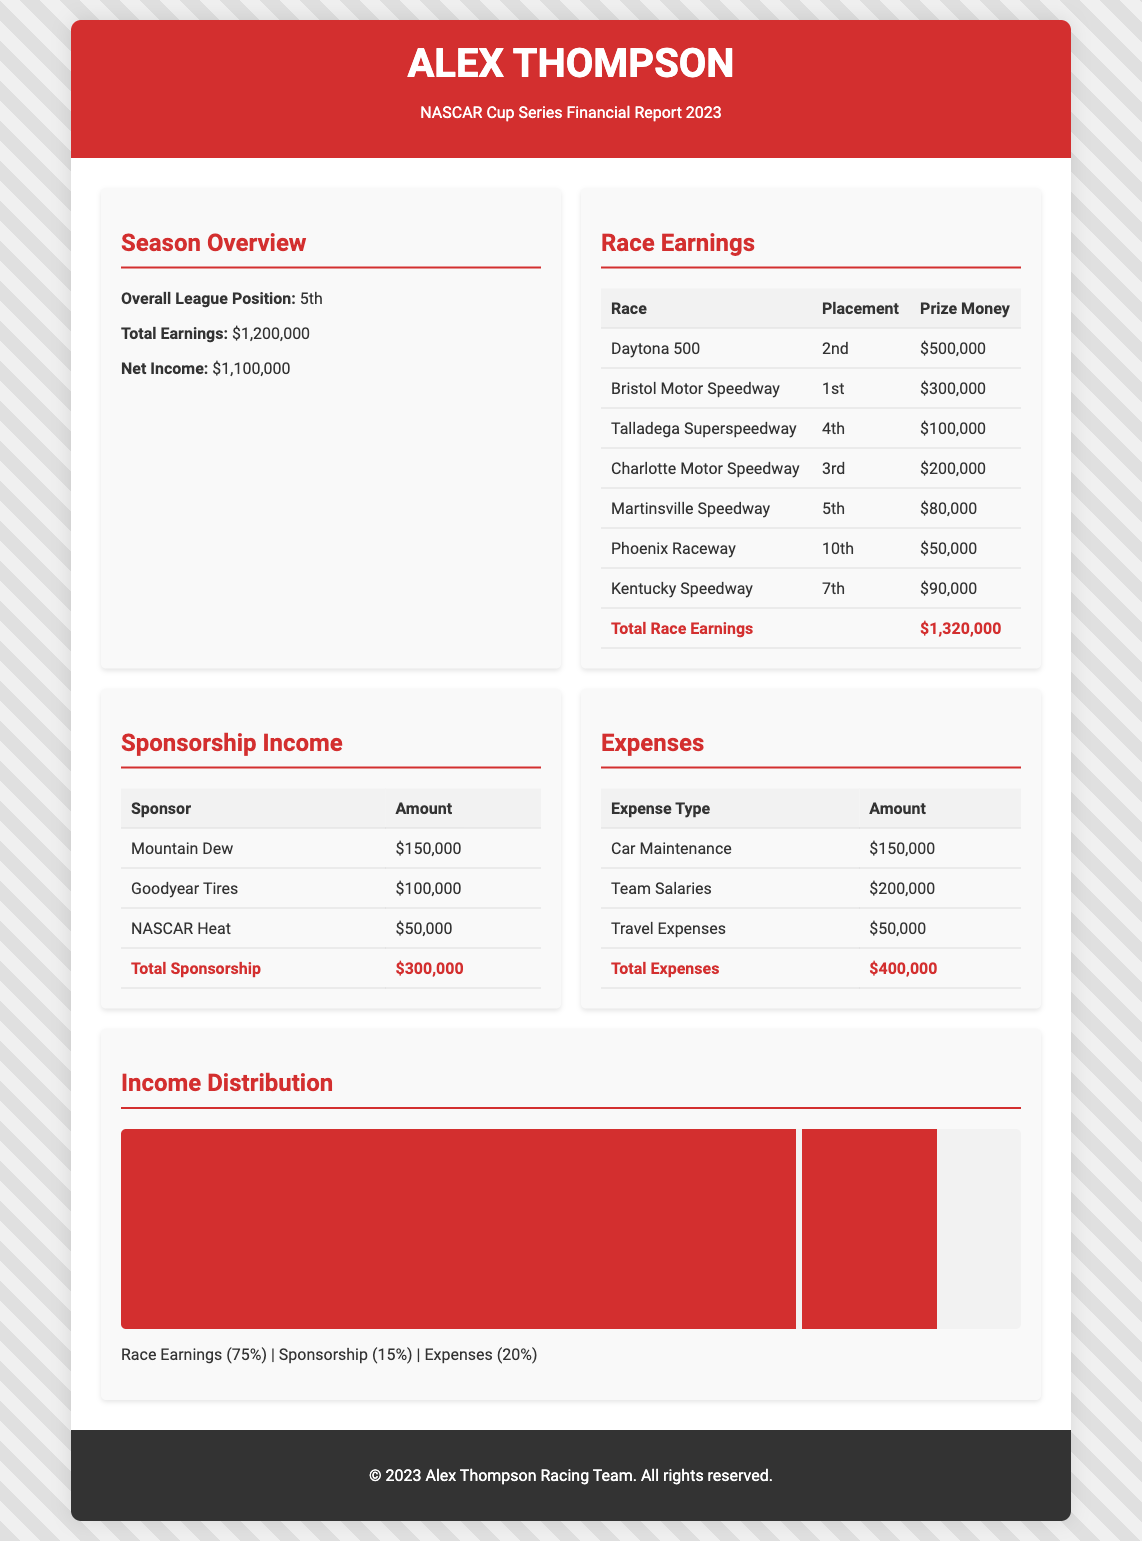What is the overall league position? The overall league position is stated in the Season Overview section of the document.
Answer: 5th What is the total earnings from prize money? The total earnings from prize money is summarized in the Race Earnings section.
Answer: $1,320,000 How much did Alex earn from the Daytona 500? The earnings from the Daytona 500 are listed in the Race Earnings table under Prize Money.
Answer: $500,000 What is the total sponsorship income? The total sponsorship income is provided in the Sponsorship Income section of the document.
Answer: $300,000 What is the total amount spent on team salaries? The total spent on team salaries is detailed in the Expenses section of the document.
Answer: $200,000 What percentage of total income comes from race earnings? The percentage is shown in the Income Distribution section, relating race earnings to total income.
Answer: 75% What was Alex Thompson's net income? Net income can be found in the Season Overview section as a direct figure.
Answer: $1,100,000 What kind of sponsorship provided the highest amount? The amount for each sponsor is listed, making it clear which is the highest.
Answer: Mountain Dew What is the total amount spent on car maintenance? The amount spent on car maintenance is explicitly detailed in the Expenses section.
Answer: $150,000 What place did Alex finish in at Bristol Motor Speedway? The placement at Bristol Motor Speedway is provided in the Race Earnings table.
Answer: 1st 